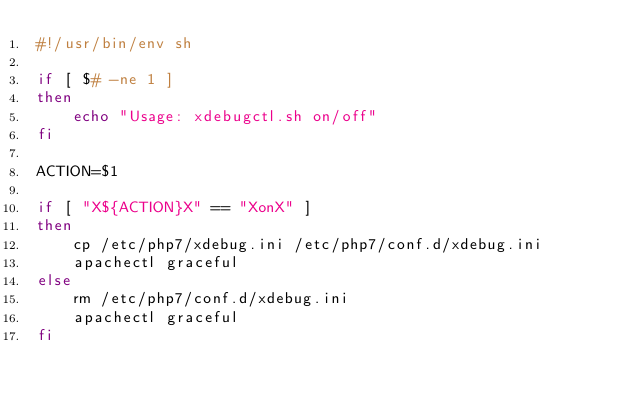<code> <loc_0><loc_0><loc_500><loc_500><_Bash_>#!/usr/bin/env sh

if [ $# -ne 1 ]
then
    echo "Usage: xdebugctl.sh on/off"
fi

ACTION=$1

if [ "X${ACTION}X" == "XonX" ]
then
    cp /etc/php7/xdebug.ini /etc/php7/conf.d/xdebug.ini
    apachectl graceful
else
    rm /etc/php7/conf.d/xdebug.ini
    apachectl graceful
fi</code> 